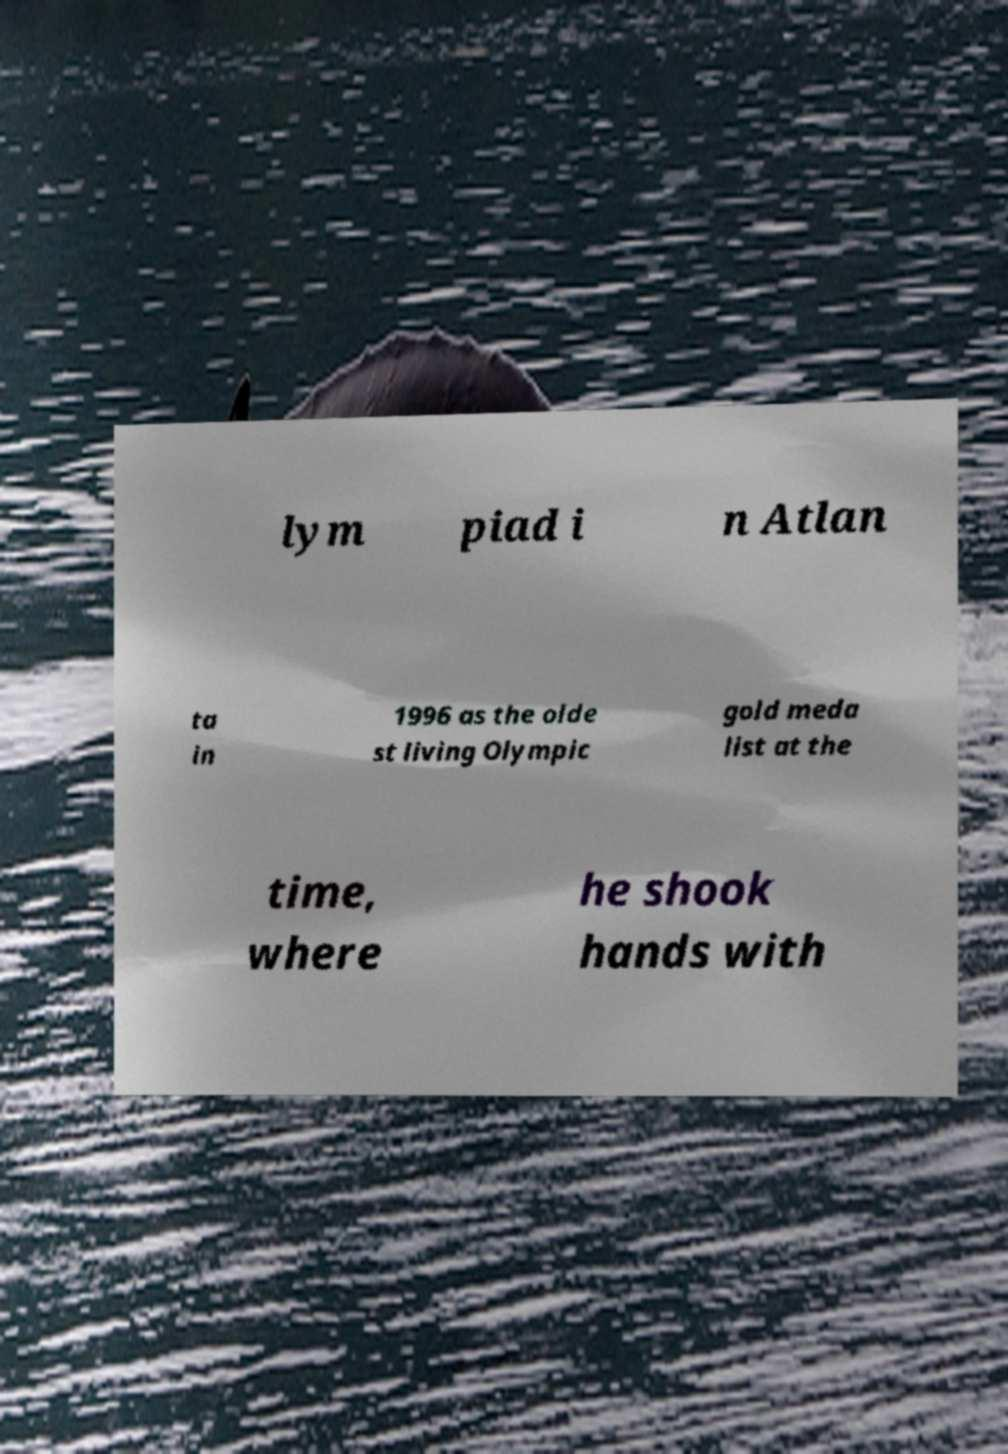Could you assist in decoding the text presented in this image and type it out clearly? lym piad i n Atlan ta in 1996 as the olde st living Olympic gold meda list at the time, where he shook hands with 